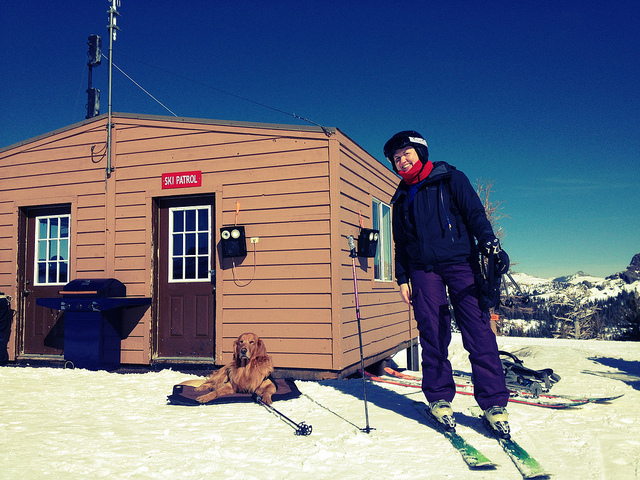Read and extract the text from this image. FATROL 